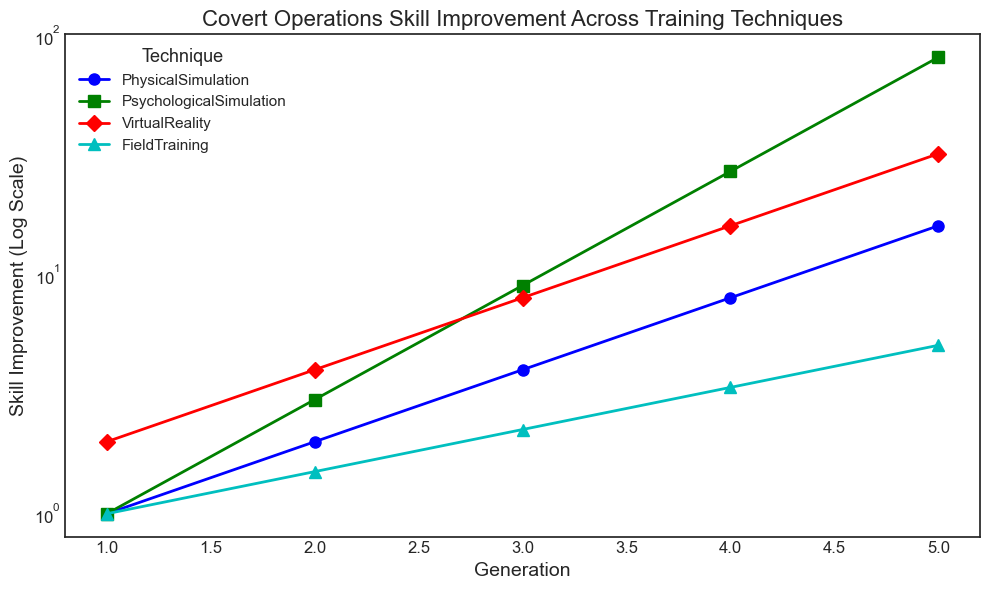Which training technique shows the highest skill improvement by Generation 5? To find out which technique shows the highest skill improvement by Generation 5, we look at the highest point on the y-axis corresponding to Generation 5. PsychologicalSimulation shows the highest skill improvement value at Generation 5.
Answer: PsychologicalSimulation How does the improvement rate of VirtualReality compare from Generation 1 to Generation 5? For VirtualReality, examine the points at Generations 1 and 5 on the plot. Skill improvement increases from 2 at Generation 1 to 32 at Generation 5.
Answer: It increases significantly Which technique has the slowest skill improvement from Generation 1 to Generation 5? To determine the slowest growth, we compare the slopes of the lines for each technique from Generation 1 to 5. FieldTraining shows the slowest growth as its line is least steep.
Answer: FieldTraining What's the average skill improvement of PhysicalSimulation across all five generations? Sum the skill improvements of PhysicalSimulation across all generations and divide by the number of generations: (1 + 2 + 4 + 8 + 16) / 5 = 31 / 5 = 6.2
Answer: 6.2 Between Generations 2 and 3, which technique shows the largest increase in skill improvement? Calculate the difference between Generations 2 and 3 for each technique. PsychologicalSimulation increases by 6 (from 3 to 9), which is the largest increase.
Answer: PsychologicalSimulation Which technique has the steepest line, indicating the fastest growing skill improvement rate, on the plot? The steepest line is identified by examining the slope of each technique's line. The line for PsychologicalSimulation is the steepest, indicating the fastest growth rate.
Answer: PsychologicalSimulation By how much does the skill improvement of FieldTraining increase from Generation 2 to Generation 4? For FieldTraining, subtract the skill improvement at Generation 2 from that at Generation 4: 3.375 - 1.5 = 1.875.
Answer: 1.875 What's the difference in skill improvement between VirtualReality and FieldTraining at Generation 3? Subtract the skill improvement of FieldTraining from VirtualReality at Generation 3: 8 - 2.25 = 5.75.
Answer: 5.75 If you compare the skill improvement at Generation 1, which two techniques have the same value? Look at the skill improvements at Generation 1 for all techniques. PhysicalSimulation and PsychologicalSimulation both have a skill improvement of 1.
Answer: PhysicalSimulation and PsychologicalSimulation 